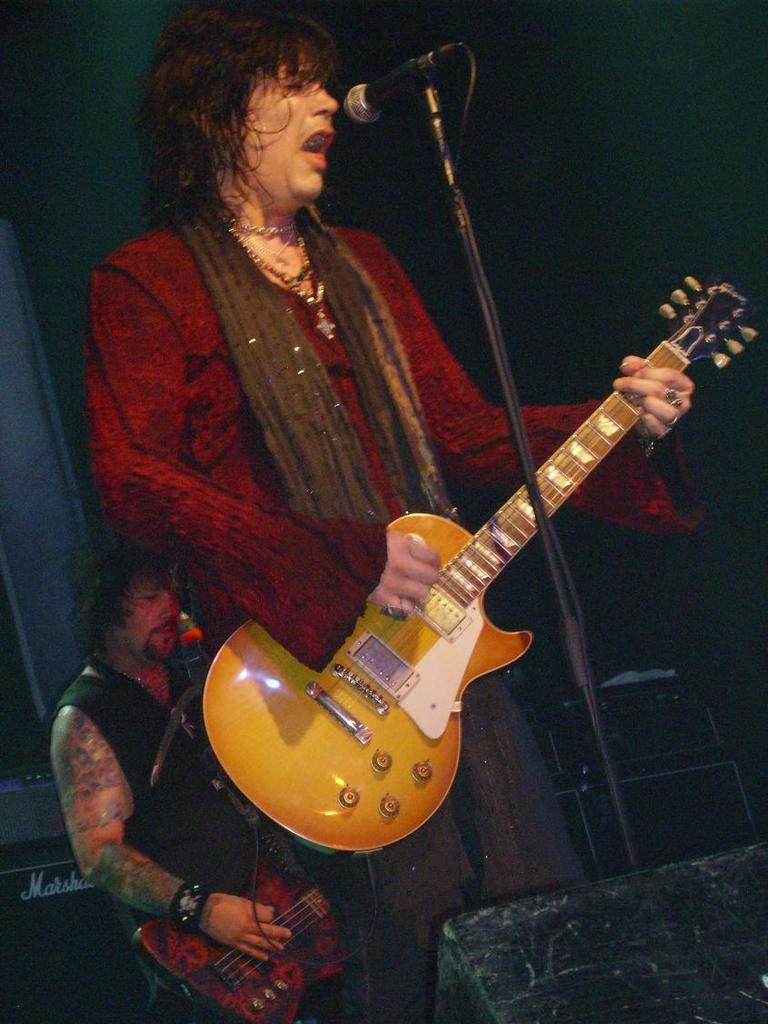Can you describe this image briefly? Two persons playing guitar,this is microphone. 